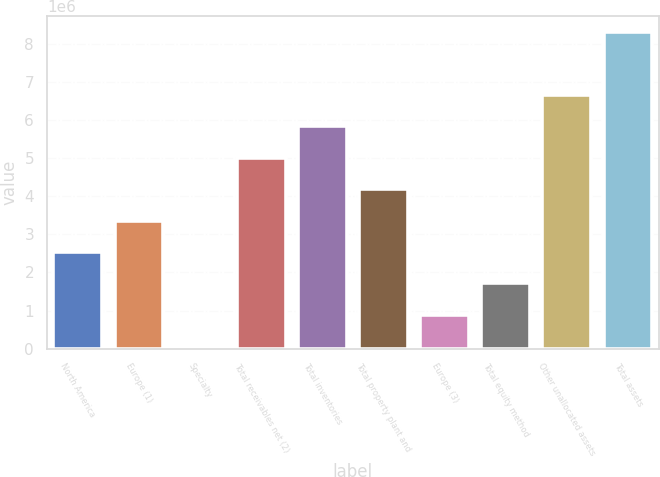<chart> <loc_0><loc_0><loc_500><loc_500><bar_chart><fcel>North America<fcel>Europe (1)<fcel>Specialty<fcel>Total receivables net (2)<fcel>Total inventories<fcel>Total property plant and<fcel>Europe (3)<fcel>Total equity method<fcel>Other unallocated assets<fcel>Total assets<nl><fcel>2.53687e+06<fcel>3.36063e+06<fcel>65587<fcel>5.00815e+06<fcel>5.83192e+06<fcel>4.18439e+06<fcel>889348<fcel>1.71311e+06<fcel>6.65568e+06<fcel>8.3032e+06<nl></chart> 